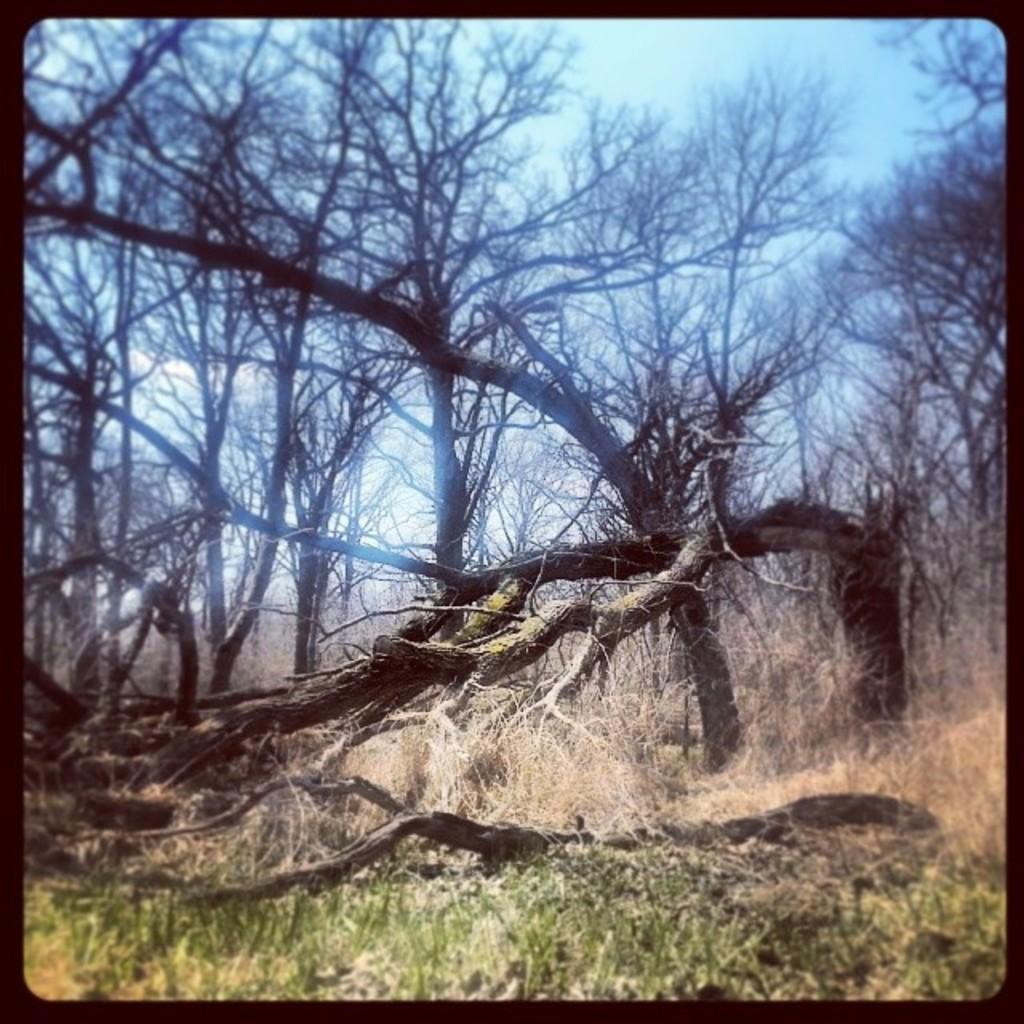Describe this image in one or two sentences. In this image I can see few trees which are brown in color and some grass which is green in color. In the background I can see the sky. 